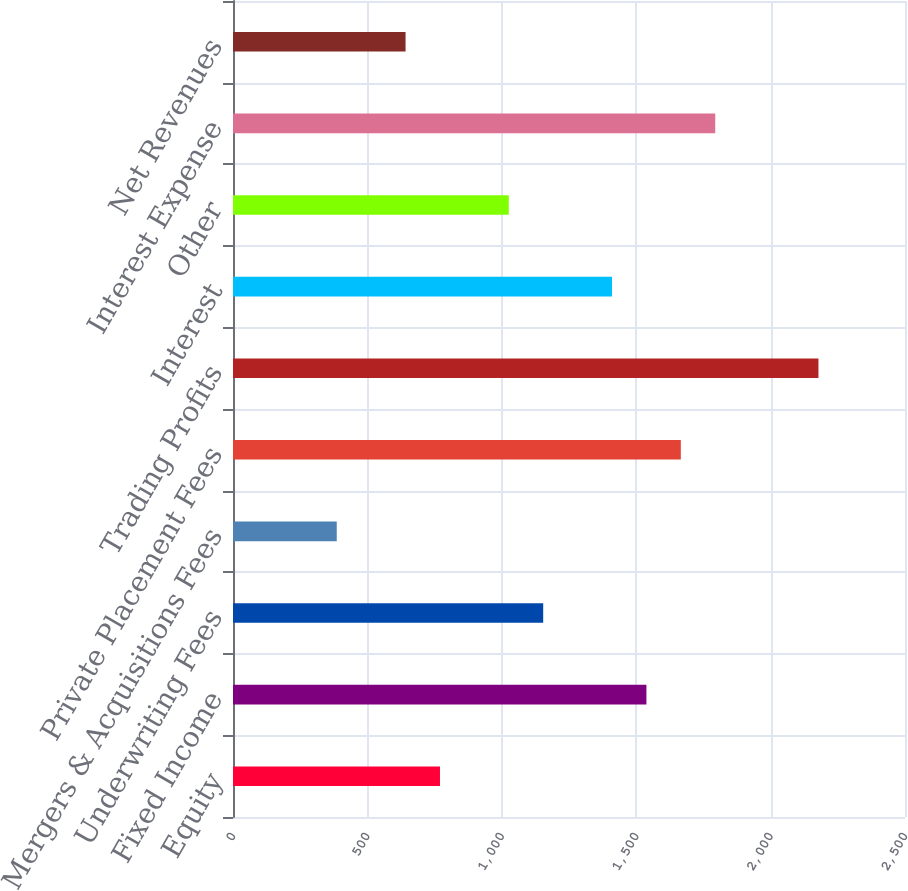Convert chart to OTSL. <chart><loc_0><loc_0><loc_500><loc_500><bar_chart><fcel>Equity<fcel>Fixed Income<fcel>Underwriting Fees<fcel>Mergers & Acquisitions Fees<fcel>Private Placement Fees<fcel>Trading Profits<fcel>Interest<fcel>Other<fcel>Interest Expense<fcel>Net Revenues<nl><fcel>770<fcel>1538<fcel>1154<fcel>386<fcel>1666<fcel>2178<fcel>1410<fcel>1026<fcel>1794<fcel>642<nl></chart> 